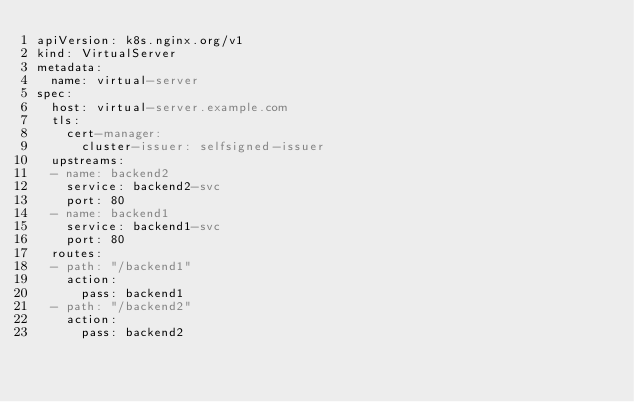<code> <loc_0><loc_0><loc_500><loc_500><_YAML_>apiVersion: k8s.nginx.org/v1
kind: VirtualServer
metadata:
  name: virtual-server
spec:
  host: virtual-server.example.com
  tls:
    cert-manager:
      cluster-issuer: selfsigned-issuer
  upstreams:
  - name: backend2
    service: backend2-svc
    port: 80
  - name: backend1
    service: backend1-svc
    port: 80
  routes:
  - path: "/backend1"
    action:
      pass: backend1
  - path: "/backend2"
    action:
      pass: backend2
</code> 